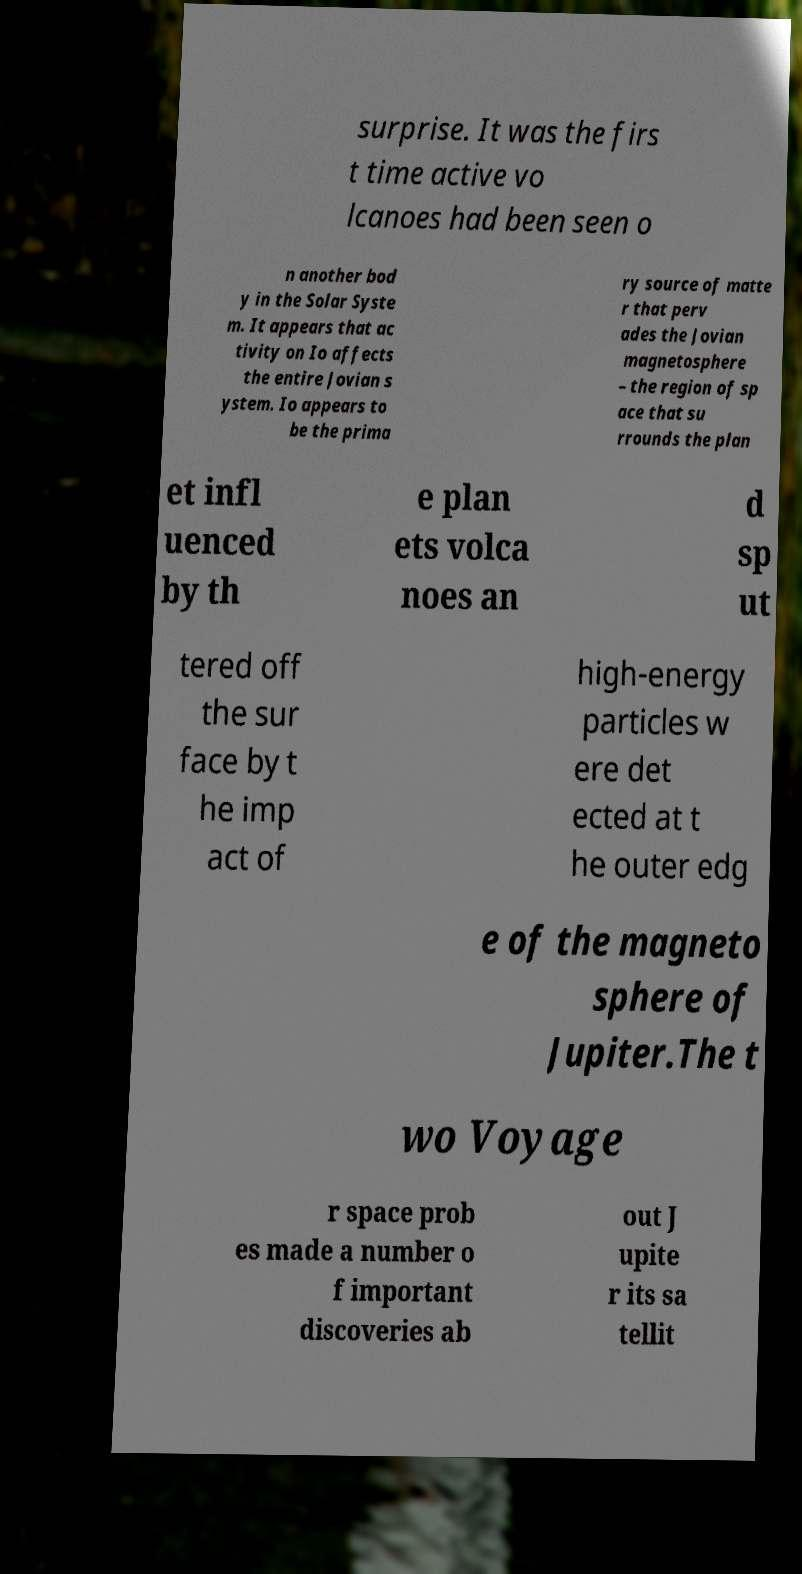Could you assist in decoding the text presented in this image and type it out clearly? surprise. It was the firs t time active vo lcanoes had been seen o n another bod y in the Solar Syste m. It appears that ac tivity on Io affects the entire Jovian s ystem. Io appears to be the prima ry source of matte r that perv ades the Jovian magnetosphere – the region of sp ace that su rrounds the plan et infl uenced by th e plan ets volca noes an d sp ut tered off the sur face by t he imp act of high-energy particles w ere det ected at t he outer edg e of the magneto sphere of Jupiter.The t wo Voyage r space prob es made a number o f important discoveries ab out J upite r its sa tellit 